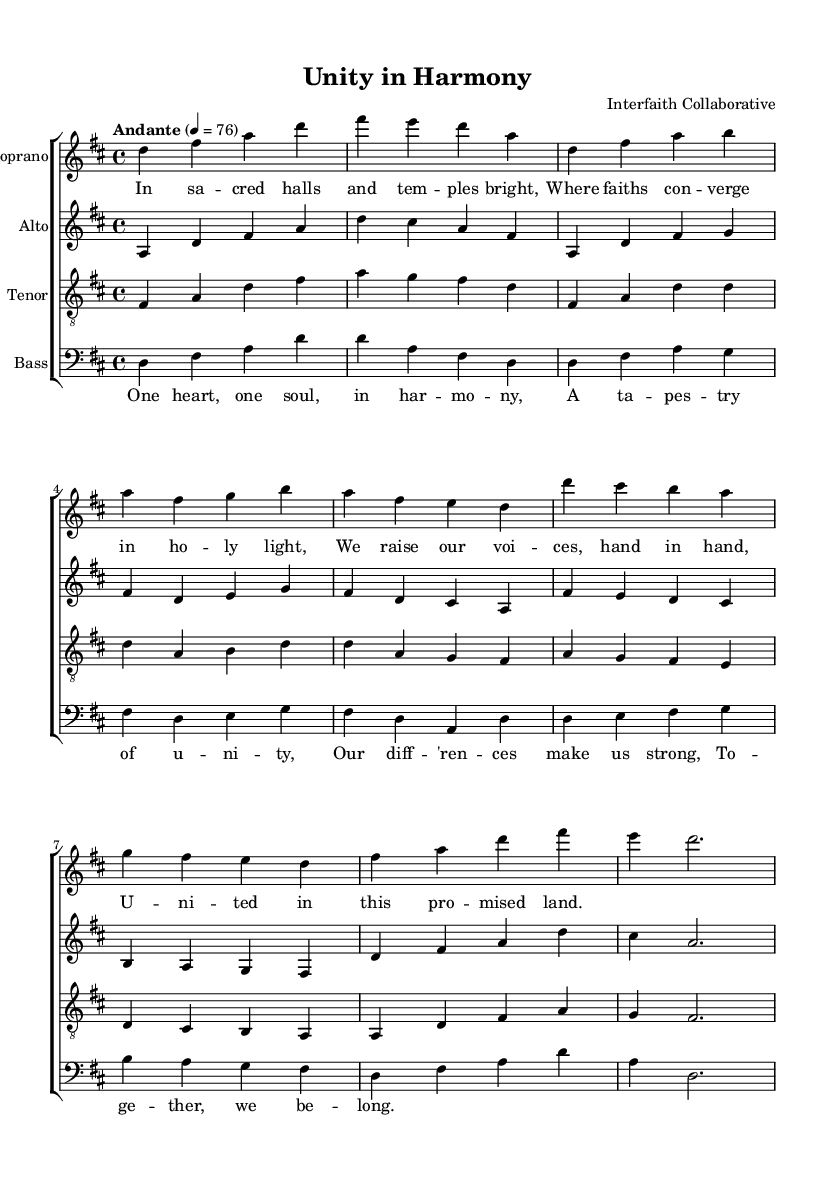What is the key signature of this music? The key signature is D major, which has two sharps (F# and C#). This can be determined by looking at the beginning of the staff where the key signature is indicated.
Answer: D major What is the time signature of the piece? The time signature is 4/4, indicated at the beginning of the sheet music. This means there are four beats per measure, and the quarter note gets one beat.
Answer: 4/4 What is the tempo marking given for this piece? The tempo marking is "Andante," which suggests a moderately slow tempo. It is specified at the beginning with a metronome marking of 76 beats per minute.
Answer: Andante How many voices are present in this choral arrangement? There are four voices: Soprano, Alto, Tenor, and Bass. This can be identified by the individual staves labeled for each vocal part.
Answer: Four What is the title of the work? The title of the work is "Unity in Harmony." This is found in the header section at the top of the sheet music.
Answer: Unity in Harmony In which vocal part do the lyrics of the chorus appear? The lyrics of the chorus are placed with the Bass part. This is noticeable where the lyrics are written below the Bass staff, specifically aligned with the musical notes.
Answer: Bass What is the theme reflected in the lyrics of the verse? The theme reflected in the lyrics of the verse is unity across different faiths. This can be deduced from the content of the lyrics, which speak of converging faiths and raising voices together.
Answer: Unity 